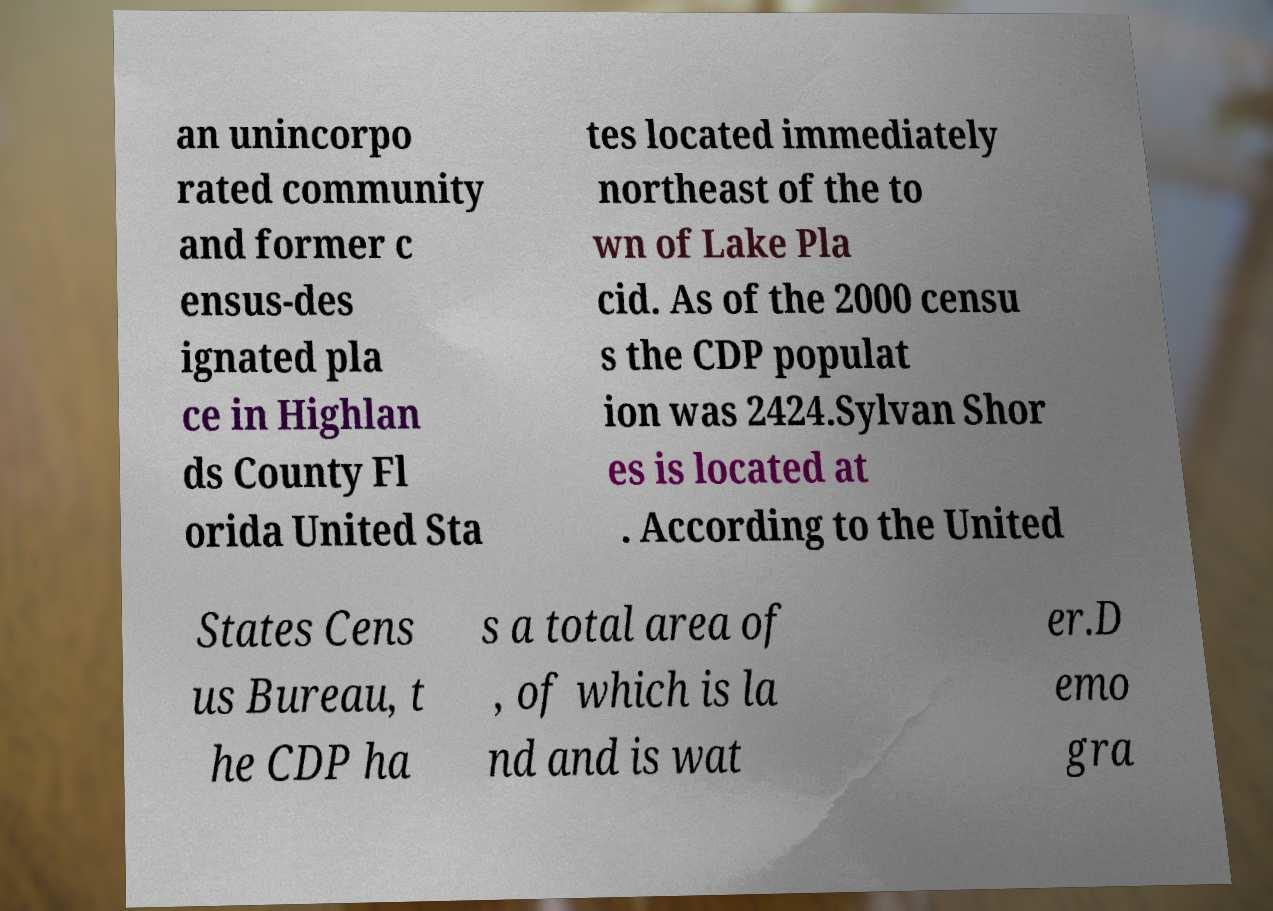Please identify and transcribe the text found in this image. an unincorpo rated community and former c ensus-des ignated pla ce in Highlan ds County Fl orida United Sta tes located immediately northeast of the to wn of Lake Pla cid. As of the 2000 censu s the CDP populat ion was 2424.Sylvan Shor es is located at . According to the United States Cens us Bureau, t he CDP ha s a total area of , of which is la nd and is wat er.D emo gra 